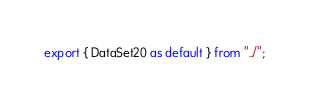Convert code to text. <code><loc_0><loc_0><loc_500><loc_500><_TypeScript_>export { DataSet20 as default } from "../";
</code> 